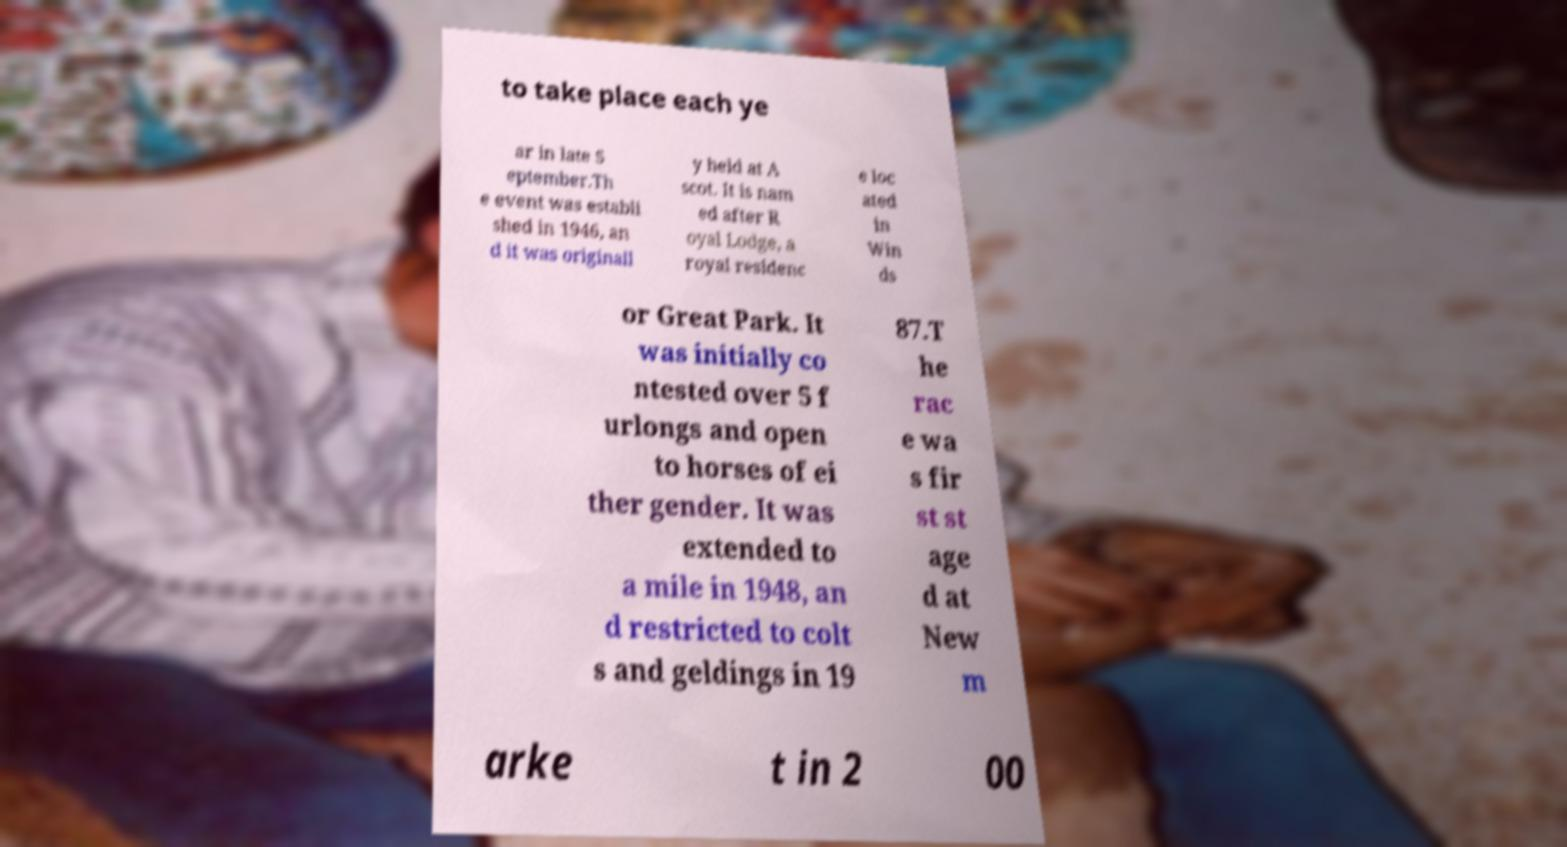For documentation purposes, I need the text within this image transcribed. Could you provide that? to take place each ye ar in late S eptember.Th e event was establi shed in 1946, an d it was originall y held at A scot. It is nam ed after R oyal Lodge, a royal residenc e loc ated in Win ds or Great Park. It was initially co ntested over 5 f urlongs and open to horses of ei ther gender. It was extended to a mile in 1948, an d restricted to colt s and geldings in 19 87.T he rac e wa s fir st st age d at New m arke t in 2 00 